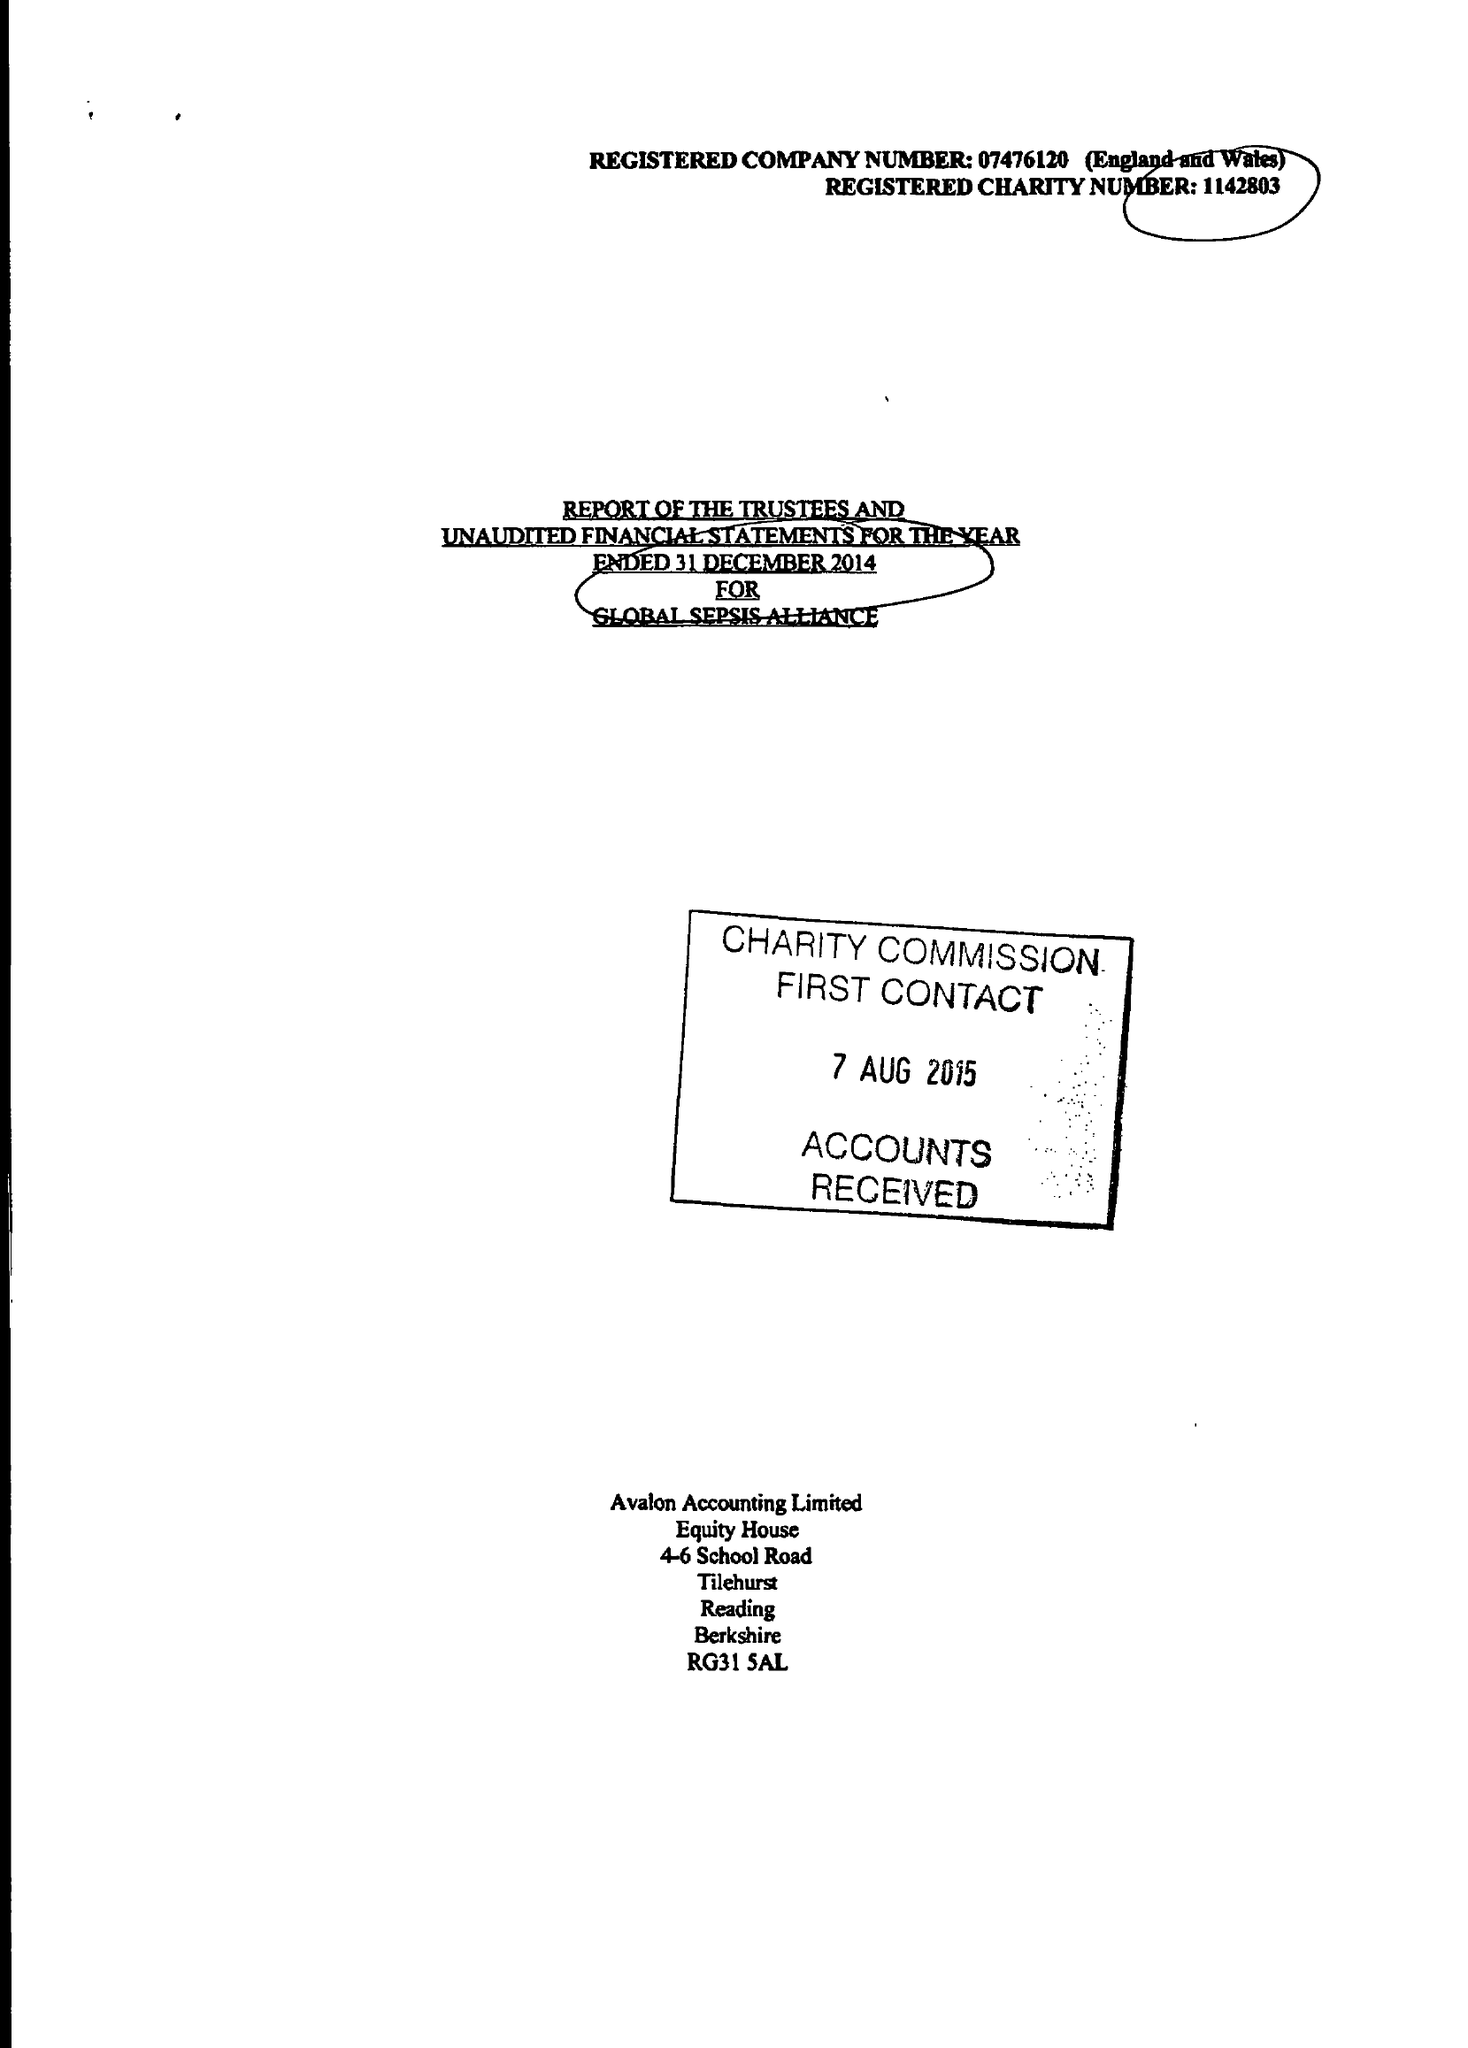What is the value for the report_date?
Answer the question using a single word or phrase. 2014-12-31 